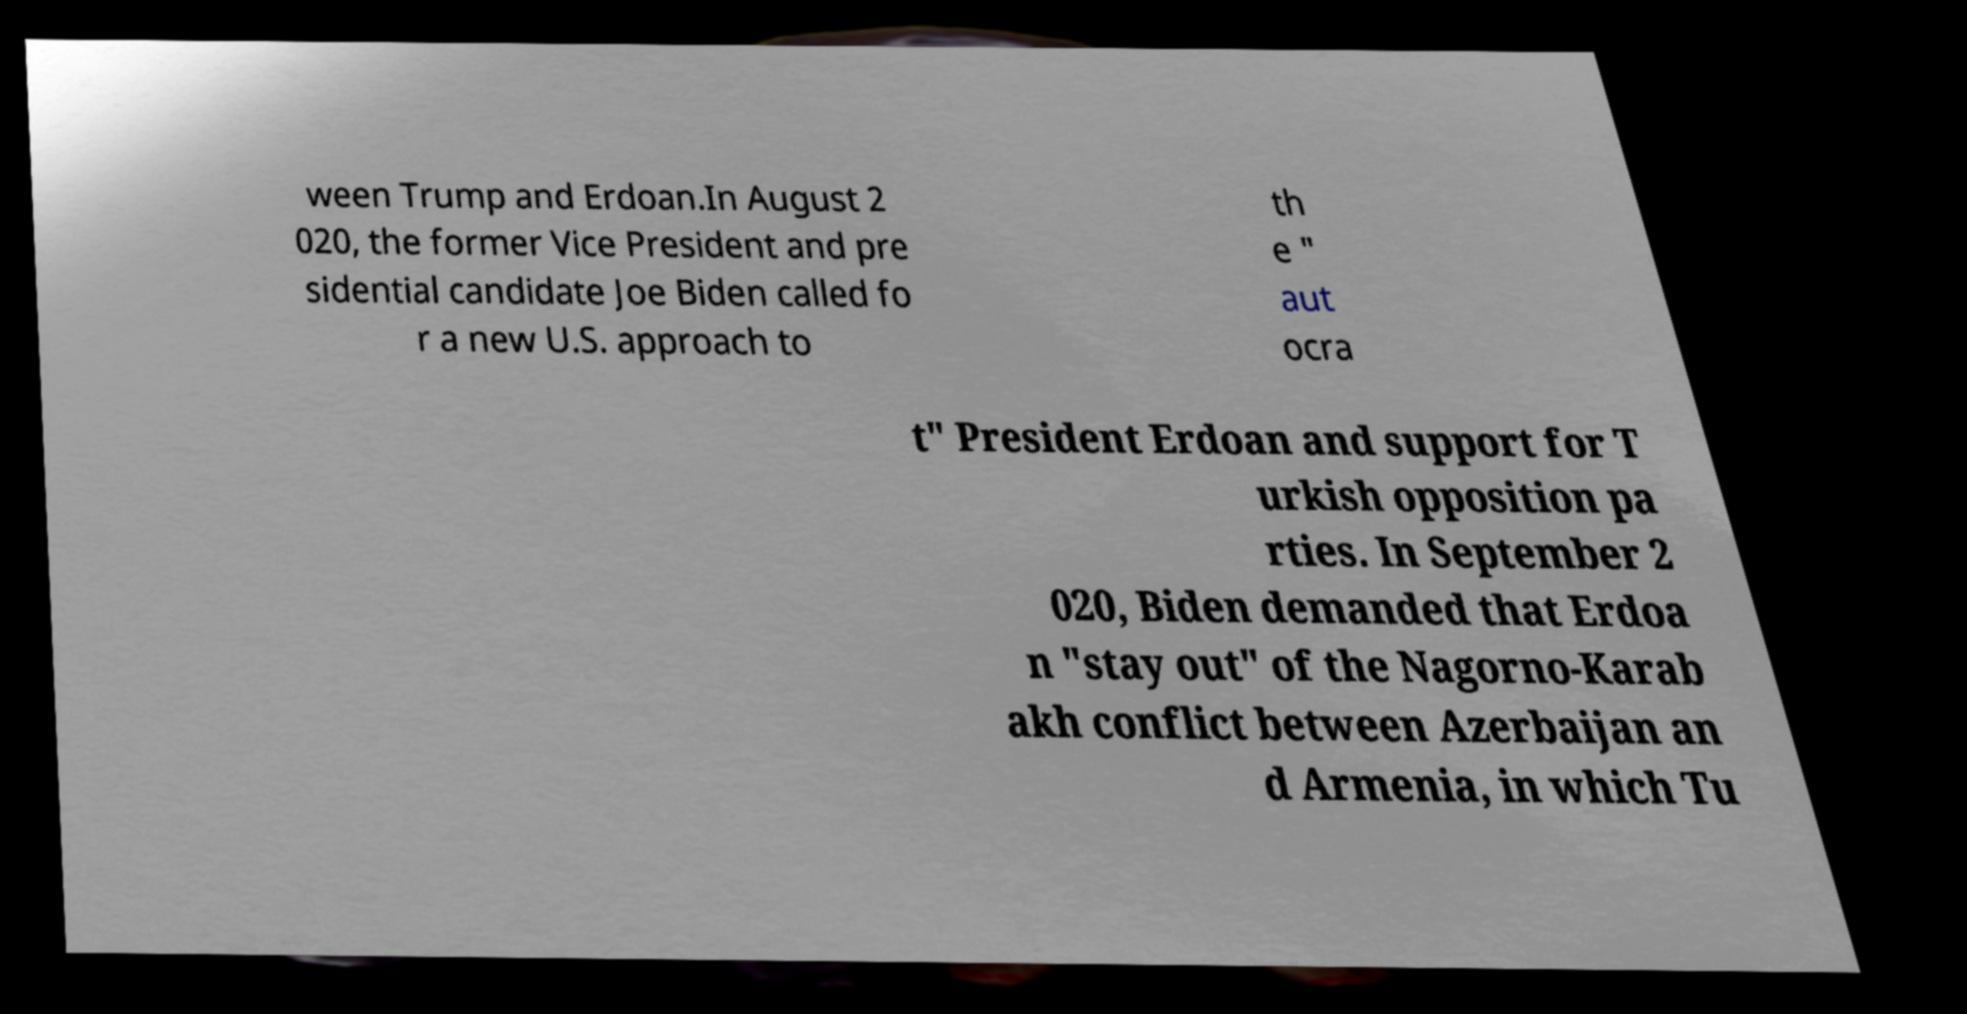Please identify and transcribe the text found in this image. ween Trump and Erdoan.In August 2 020, the former Vice President and pre sidential candidate Joe Biden called fo r a new U.S. approach to th e " aut ocra t" President Erdoan and support for T urkish opposition pa rties. In September 2 020, Biden demanded that Erdoa n "stay out" of the Nagorno-Karab akh conflict between Azerbaijan an d Armenia, in which Tu 